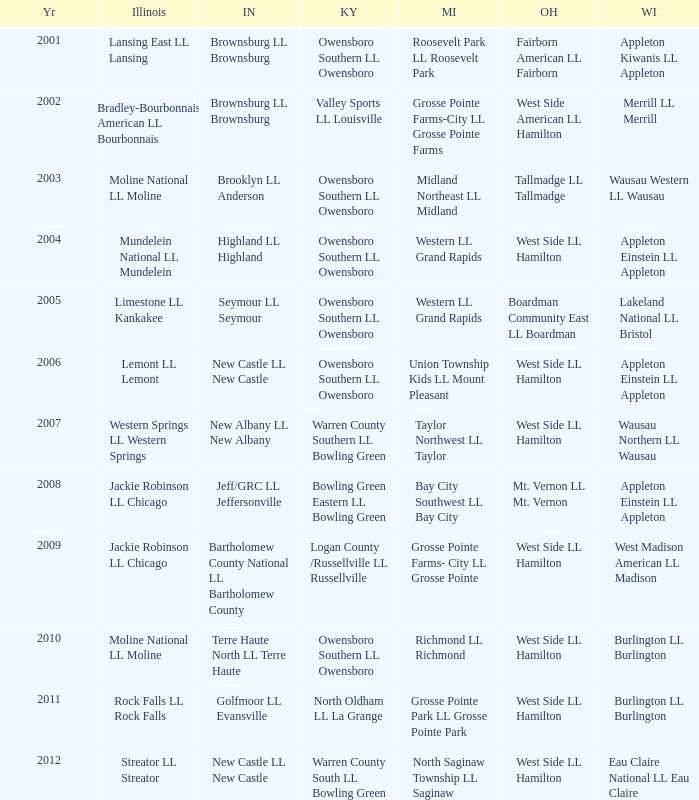What was the little league team from Kentucky when the little league team from Illinois was Rock Falls LL Rock Falls? North Oldham LL La Grange. 